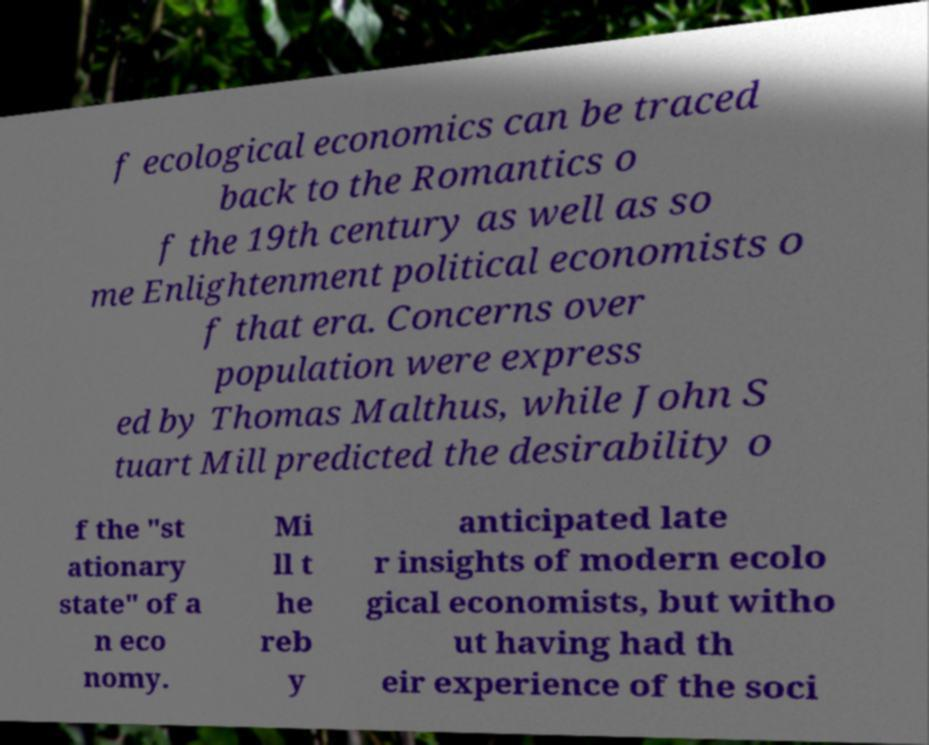I need the written content from this picture converted into text. Can you do that? f ecological economics can be traced back to the Romantics o f the 19th century as well as so me Enlightenment political economists o f that era. Concerns over population were express ed by Thomas Malthus, while John S tuart Mill predicted the desirability o f the "st ationary state" of a n eco nomy. Mi ll t he reb y anticipated late r insights of modern ecolo gical economists, but witho ut having had th eir experience of the soci 